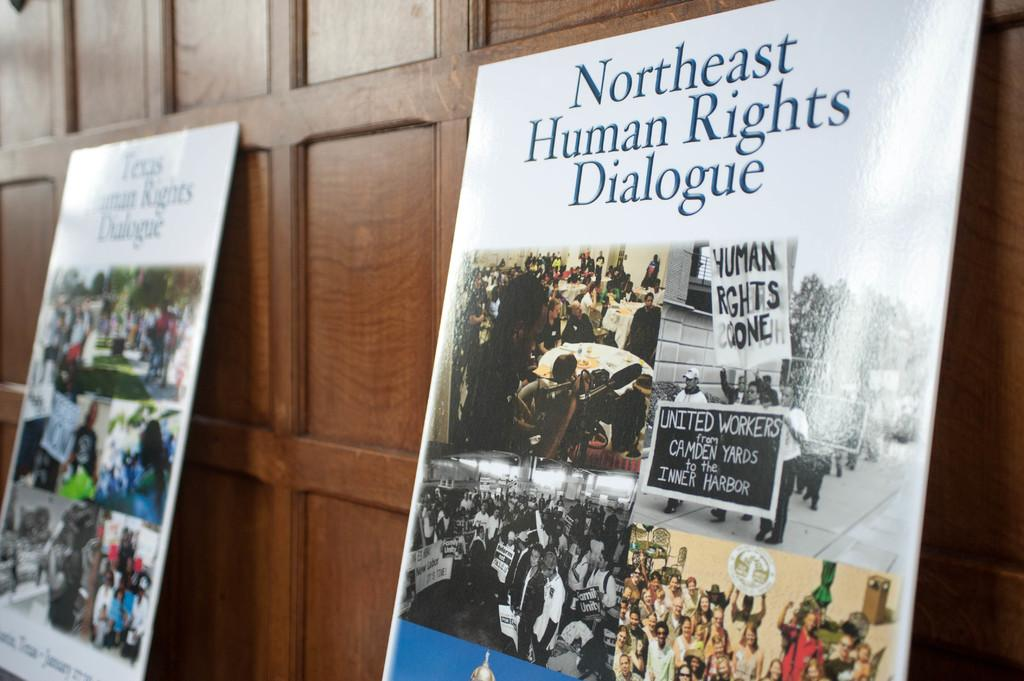Provide a one-sentence caption for the provided image. A poster with Human Rights pictures on them with the words Northeast Human Rights Dialogoue. 